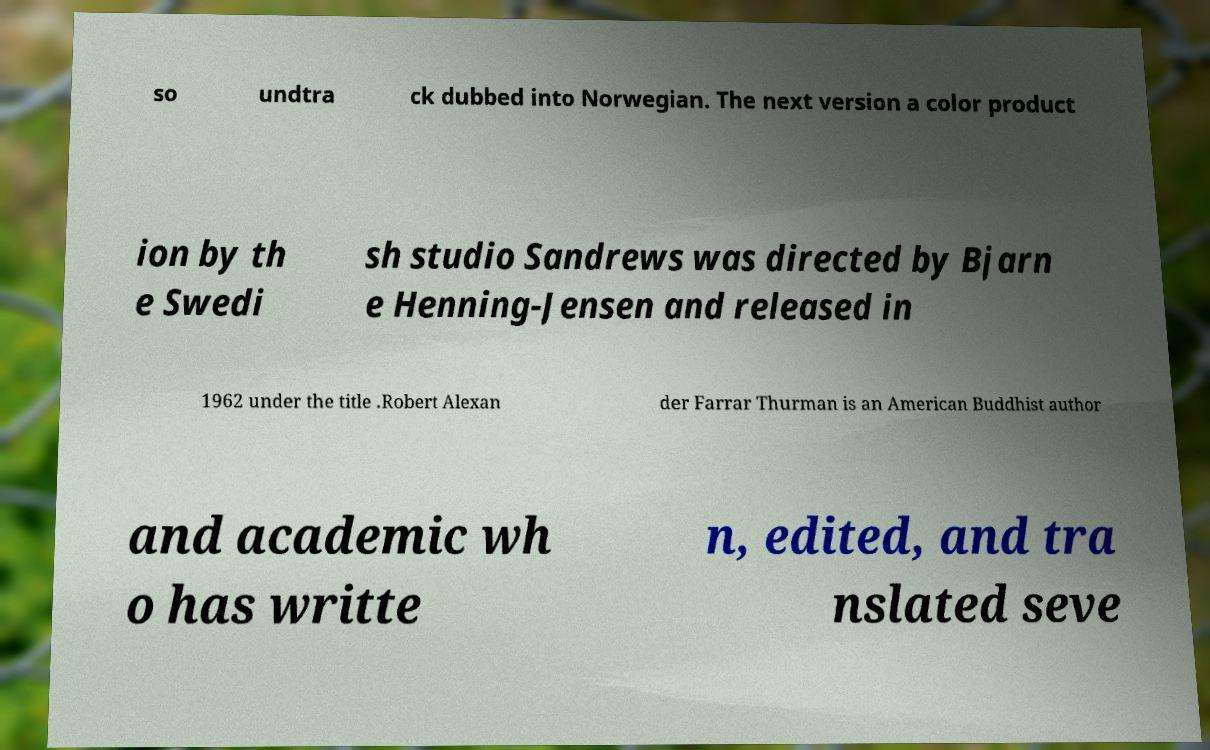Can you accurately transcribe the text from the provided image for me? so undtra ck dubbed into Norwegian. The next version a color product ion by th e Swedi sh studio Sandrews was directed by Bjarn e Henning-Jensen and released in 1962 under the title .Robert Alexan der Farrar Thurman is an American Buddhist author and academic wh o has writte n, edited, and tra nslated seve 